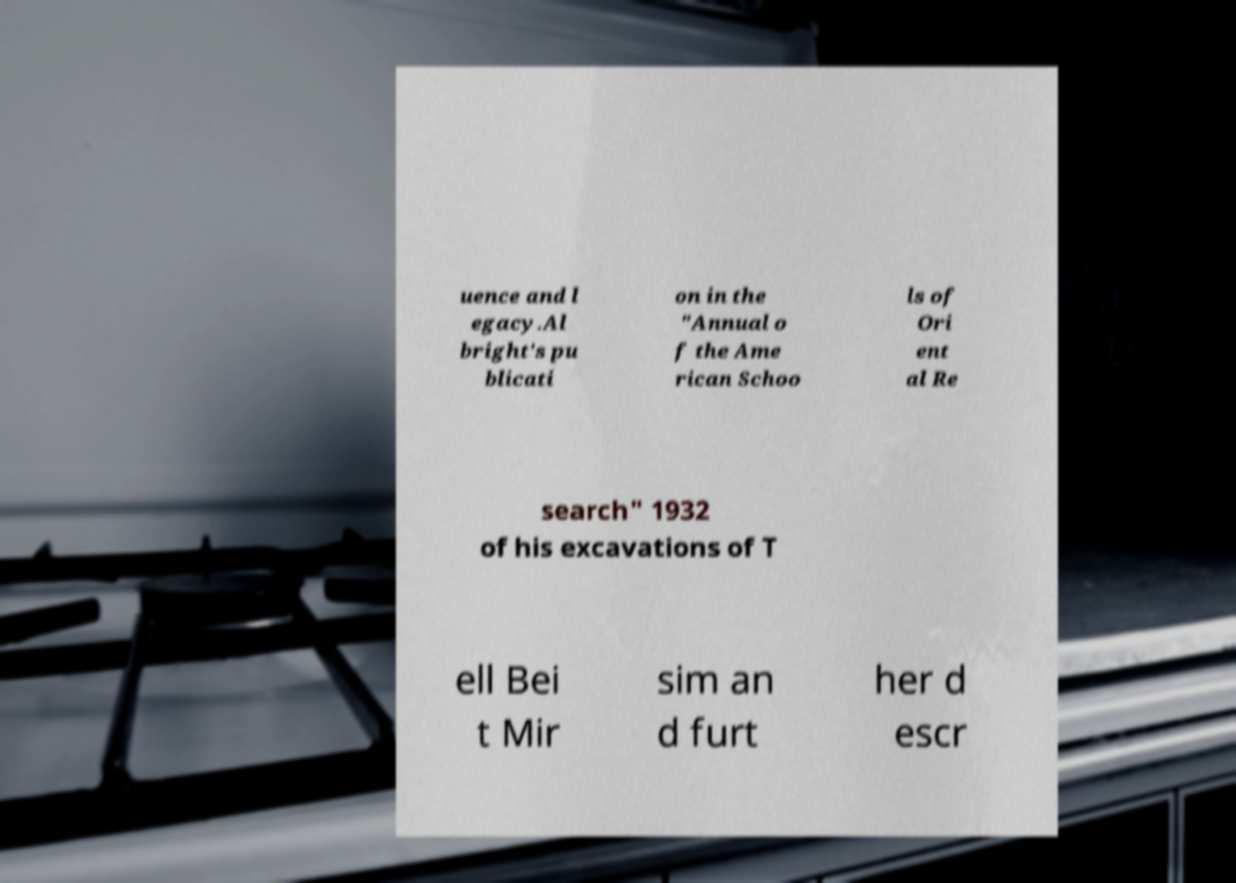There's text embedded in this image that I need extracted. Can you transcribe it verbatim? uence and l egacy.Al bright's pu blicati on in the "Annual o f the Ame rican Schoo ls of Ori ent al Re search" 1932 of his excavations of T ell Bei t Mir sim an d furt her d escr 